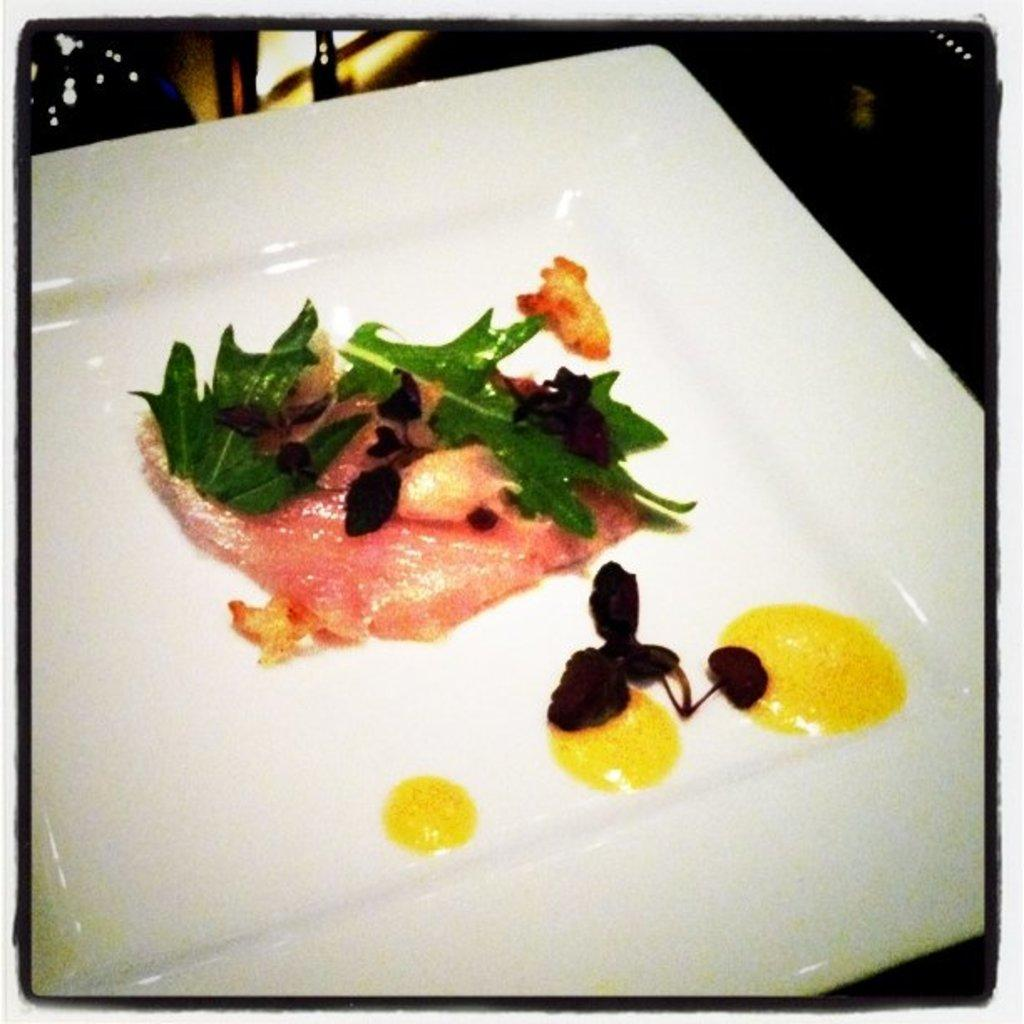What object is present in the image that can hold food? There is a plate in the image. What color is the plate? The plate is white. What is on the plate? There are eatables on the plate. What type of button is the woman wearing on her shirt in the image? There is no woman or button present in the image; it only features a plate with eatables. 